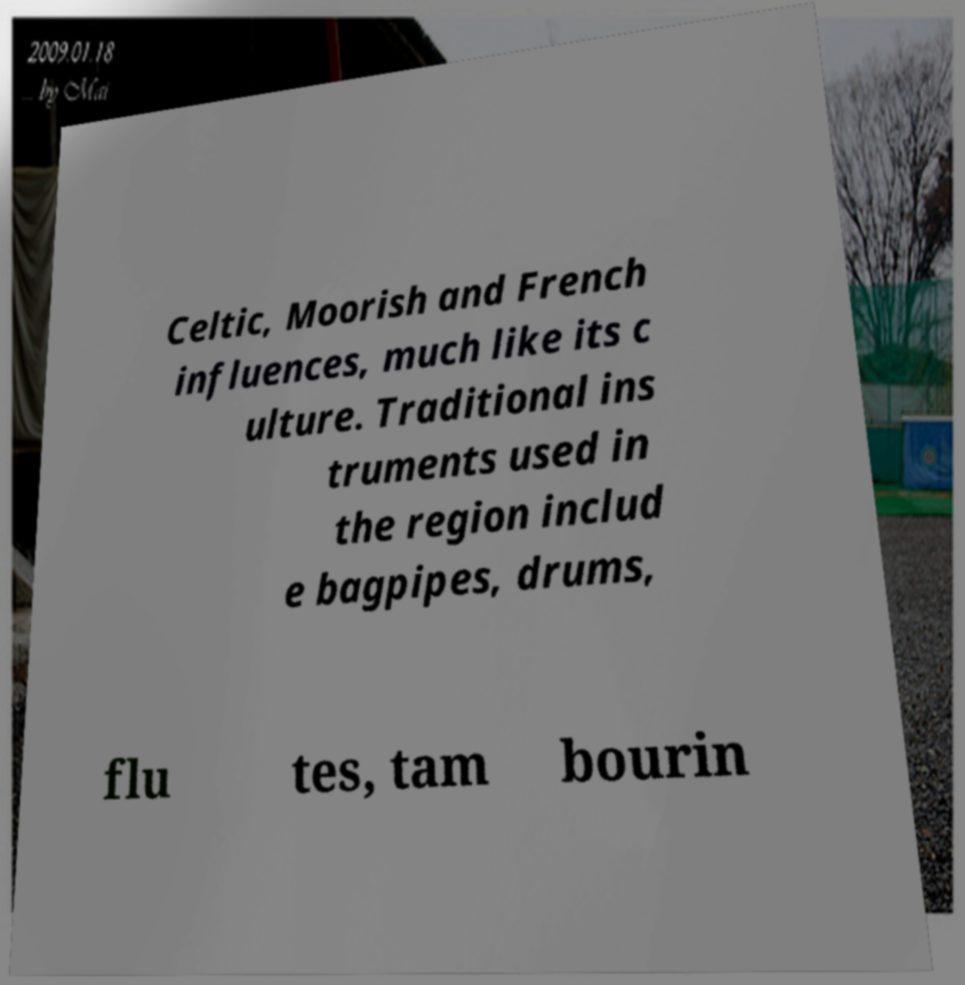Please identify and transcribe the text found in this image. Celtic, Moorish and French influences, much like its c ulture. Traditional ins truments used in the region includ e bagpipes, drums, flu tes, tam bourin 